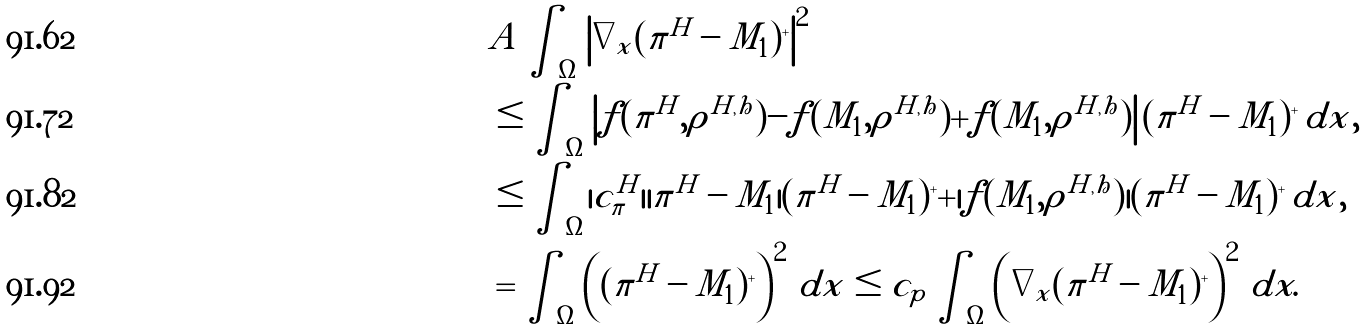<formula> <loc_0><loc_0><loc_500><loc_500>& A \int _ { \Omega } \left | \nabla _ { x } ( \pi ^ { H } - M _ { 1 } ) ^ { + } \right | ^ { 2 } \\ & \leq \int _ { \Omega } \left | f ( \pi ^ { H } , \rho ^ { H , h } ) - f ( M _ { 1 } , \rho ^ { H , h } ) + f ( M _ { 1 } , \rho ^ { H , h } ) \right | ( \pi ^ { H } - M _ { 1 } ) ^ { + } \, d x , \\ & \leq \int _ { \Omega } | c _ { \pi } ^ { H } | | \pi ^ { H } - M _ { 1 } | ( \pi ^ { H } - M _ { 1 } ) ^ { + } + | f ( M _ { 1 } , \rho ^ { H , h } ) | ( \pi ^ { H } - M _ { 1 } ) ^ { + } \, d x , \\ & = \int _ { \Omega } \left ( ( \pi ^ { H } - M _ { 1 } ) ^ { + } \right ) ^ { 2 } \, d x \leq c _ { p } \int _ { \Omega } \left ( \nabla _ { x } ( \pi ^ { H } - M _ { 1 } ) ^ { + } \right ) ^ { 2 } \, d x .</formula> 